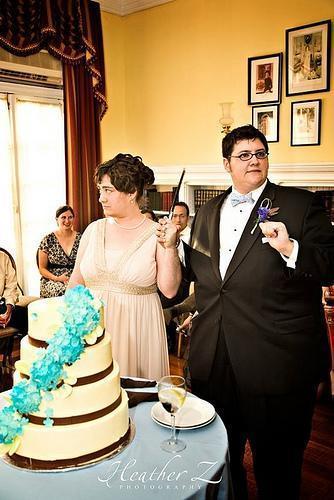How many layers is this cake?
Give a very brief answer. 4. How many tiers is the cake?
Give a very brief answer. 4. How many people are in the picture?
Give a very brief answer. 3. 